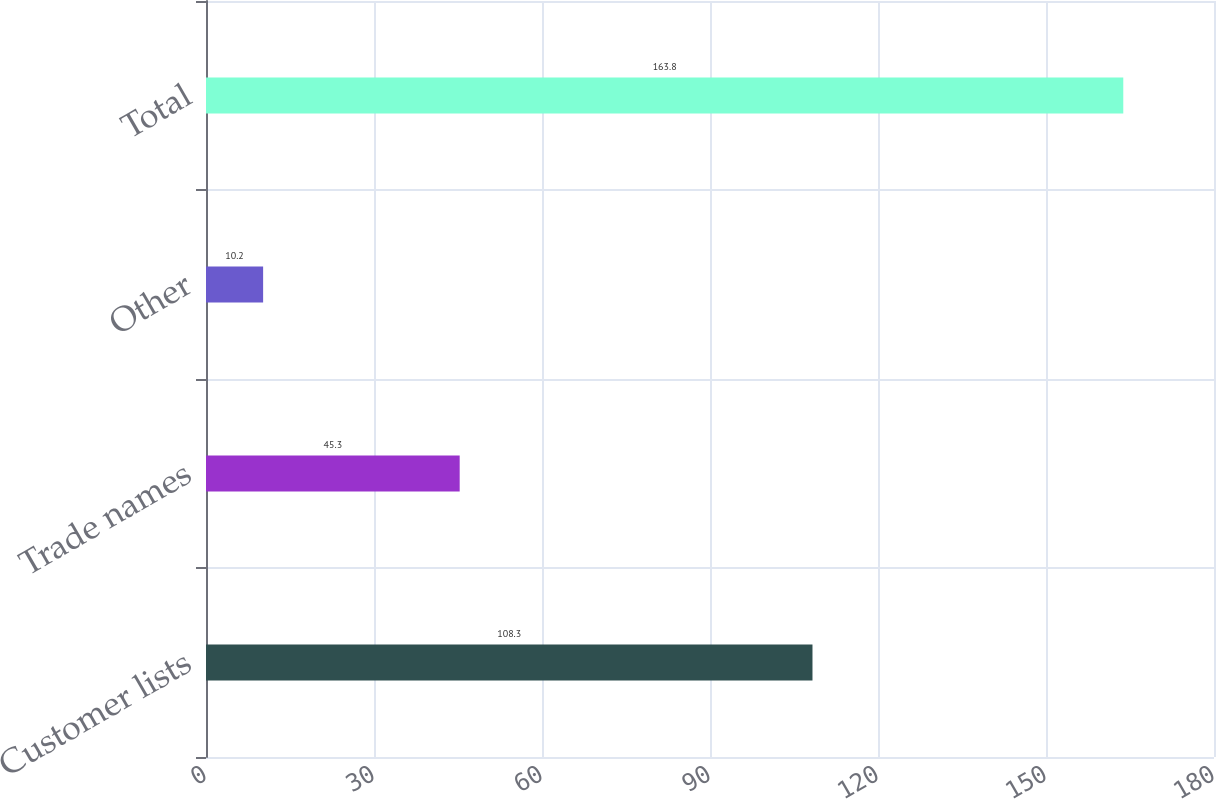<chart> <loc_0><loc_0><loc_500><loc_500><bar_chart><fcel>Customer lists<fcel>Trade names<fcel>Other<fcel>Total<nl><fcel>108.3<fcel>45.3<fcel>10.2<fcel>163.8<nl></chart> 